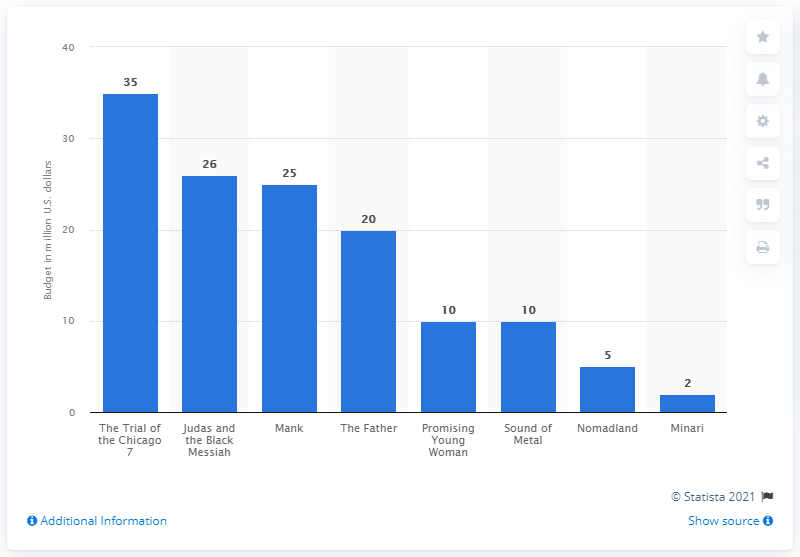Point out several critical features in this image. The cost of the Trial of the Chicago 7 was $35 million. 